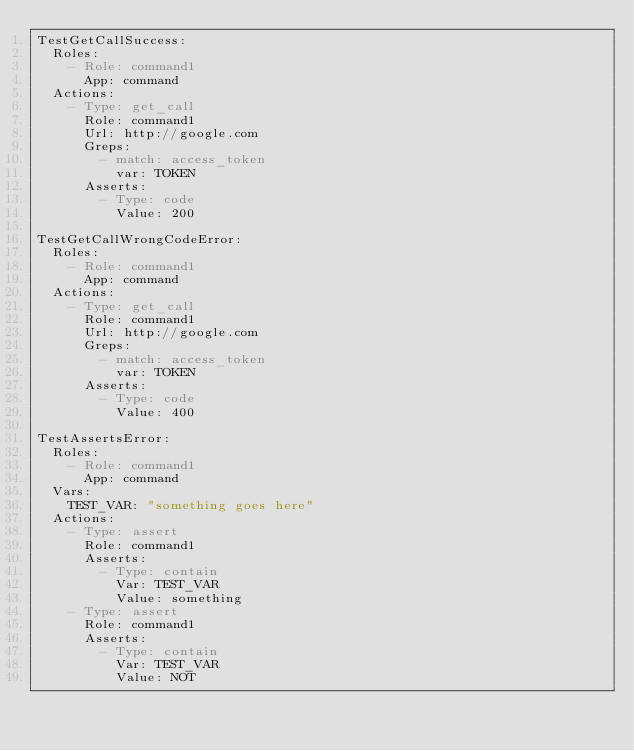<code> <loc_0><loc_0><loc_500><loc_500><_YAML_>TestGetCallSuccess:
  Roles:
    - Role: command1
      App: command
  Actions:
    - Type: get_call
      Role: command1
      Url: http://google.com
      Greps:
        - match: access_token
          var: TOKEN
      Asserts:
        - Type: code
          Value: 200 

TestGetCallWrongCodeError:
  Roles:
    - Role: command1
      App: command
  Actions:
    - Type: get_call
      Role: command1
      Url: http://google.com
      Greps:
        - match: access_token
          var: TOKEN
      Asserts:
        - Type: code
          Value: 400

TestAssertsError:
  Roles:
    - Role: command1
      App: command
  Vars:
    TEST_VAR: "something goes here"
  Actions:
    - Type: assert
      Role: command1
      Asserts:
        - Type: contain
          Var: TEST_VAR
          Value: something
    - Type: assert
      Role: command1
      Asserts:
        - Type: contain
          Var: TEST_VAR
          Value: NOT
</code> 